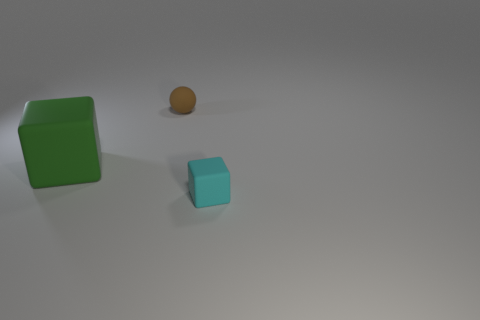How many cylinders are either green matte objects or small brown matte objects?
Offer a terse response. 0. There is a sphere that is the same material as the green block; what color is it?
Offer a terse response. Brown. Does the block that is right of the green matte block have the same size as the large green matte block?
Keep it short and to the point. No. The rubber block that is to the right of the small sphere is what color?
Your answer should be compact. Cyan. There is a matte block right of the green matte thing; is there a brown ball in front of it?
Offer a very short reply. No. What number of things are on the left side of the ball?
Offer a terse response. 1. What number of blocks have the same color as the big rubber thing?
Your answer should be very brief. 0. What number of blocks have the same material as the tiny brown thing?
Your answer should be very brief. 2. Are there more objects to the left of the small brown matte object than large purple rubber balls?
Keep it short and to the point. Yes. Is there another rubber object of the same shape as the green object?
Your response must be concise. Yes. 